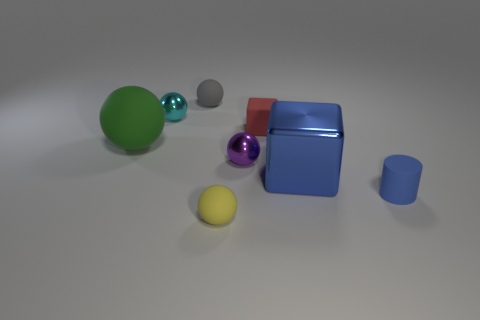Subtract 1 balls. How many balls are left? 4 Subtract all yellow balls. How many balls are left? 4 Subtract all green spheres. How many spheres are left? 4 Add 1 small gray objects. How many objects exist? 9 Subtract all yellow spheres. Subtract all purple blocks. How many spheres are left? 4 Subtract all cylinders. How many objects are left? 7 Add 7 large green spheres. How many large green spheres exist? 8 Subtract 0 brown balls. How many objects are left? 8 Subtract all small purple balls. Subtract all blue objects. How many objects are left? 5 Add 1 small blue rubber objects. How many small blue rubber objects are left? 2 